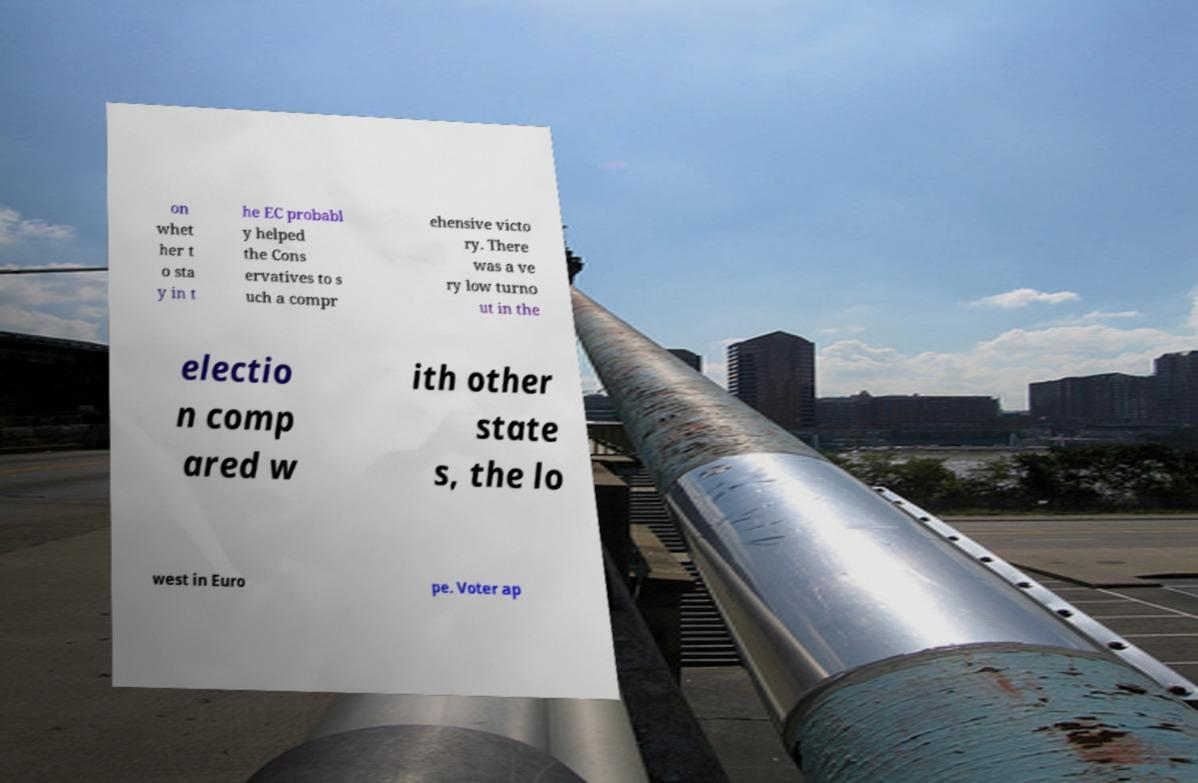Please identify and transcribe the text found in this image. on whet her t o sta y in t he EC probabl y helped the Cons ervatives to s uch a compr ehensive victo ry. There was a ve ry low turno ut in the electio n comp ared w ith other state s, the lo west in Euro pe. Voter ap 